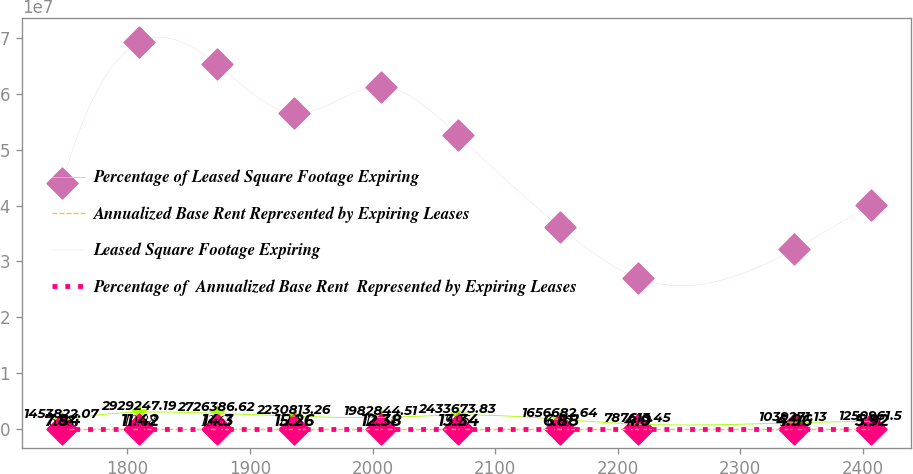<chart> <loc_0><loc_0><loc_500><loc_500><line_chart><ecel><fcel>Percentage of Leased Square Footage Expiring<fcel>Annualized Base Rent Represented by Expiring Leases<fcel>Leased Square Footage Expiring<fcel>Percentage of  Annualized Base Rent  Represented by Expiring Leases<nl><fcel>1746.67<fcel>1.45382e+06<fcel>7.84<fcel>4.40722e+07<fcel>6.98<nl><fcel>1809.79<fcel>2.92925e+06<fcel>11.42<fcel>6.9289e+07<fcel>10.88<nl><fcel>1872.9<fcel>2.72639e+06<fcel>14.3<fcel>6.53047e+07<fcel>13.67<nl><fcel>1936.02<fcel>2.23081e+06<fcel>15.26<fcel>5.65467e+07<fcel>11.81<nl><fcel>2006.61<fcel>1.98284e+06<fcel>12.38<fcel>6.13204e+07<fcel>12.74<nl><fcel>2069.72<fcel>2.43367e+06<fcel>13.34<fcel>5.25624e+07<fcel>9.95<nl><fcel>2153.04<fcel>1.65668e+06<fcel>6.88<fcel>3.61036e+07<fcel>6.05<nl><fcel>2216.15<fcel>787613<fcel>4<fcel>2.70337e+07<fcel>4.19<nl><fcel>2343.49<fcel>1.03927e+06<fcel>4.96<fcel>3.21193e+07<fcel>5.12<nl><fcel>2406.6<fcel>1.25096e+06<fcel>5.92<fcel>4.00879e+07<fcel>7.91<nl></chart> 